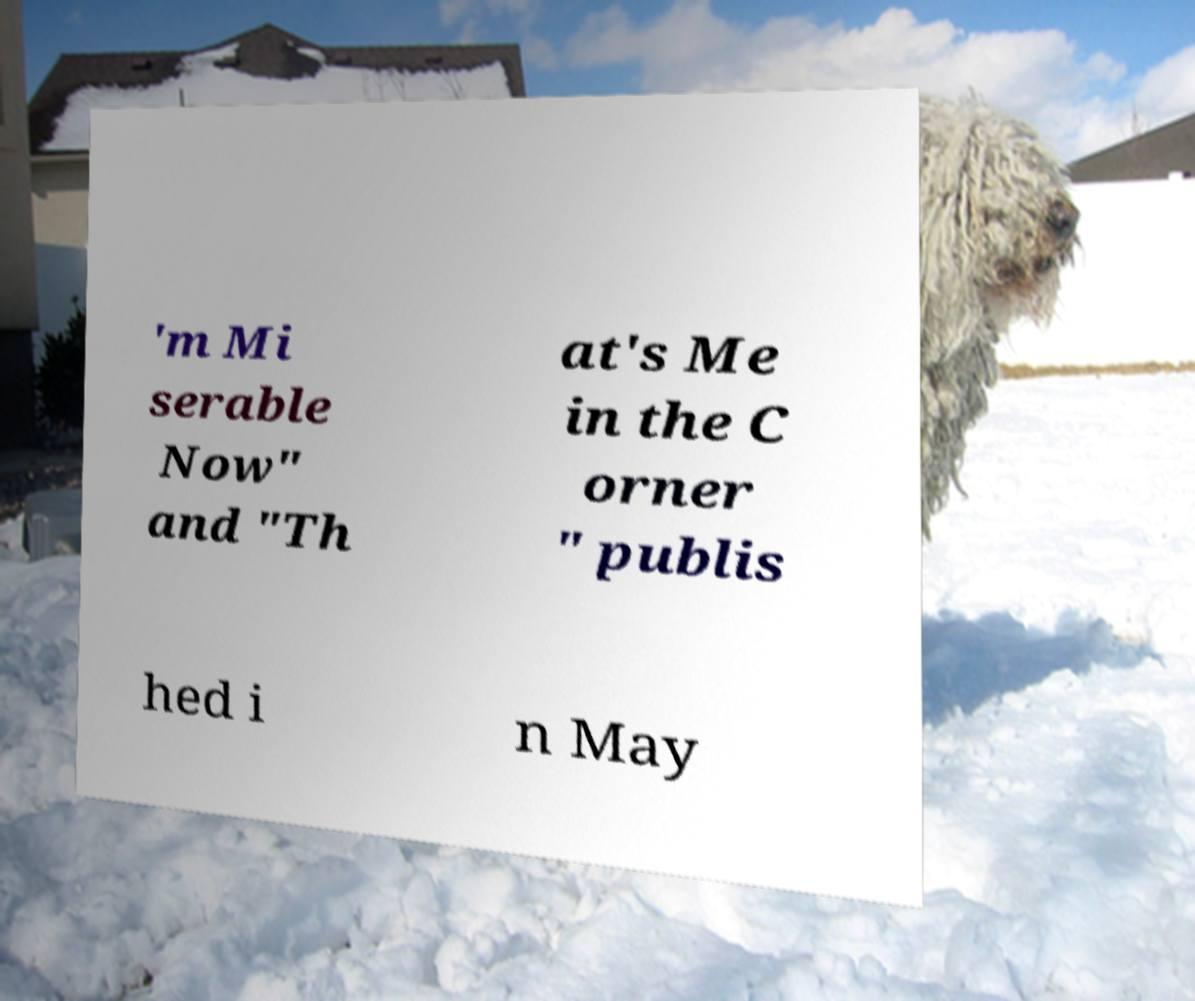For documentation purposes, I need the text within this image transcribed. Could you provide that? 'm Mi serable Now" and "Th at's Me in the C orner " publis hed i n May 